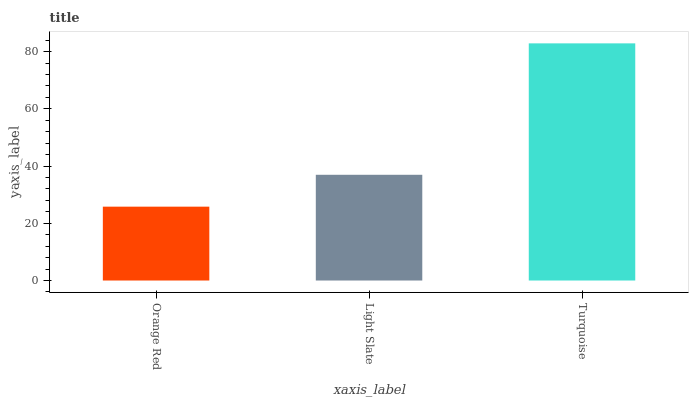Is Orange Red the minimum?
Answer yes or no. Yes. Is Turquoise the maximum?
Answer yes or no. Yes. Is Light Slate the minimum?
Answer yes or no. No. Is Light Slate the maximum?
Answer yes or no. No. Is Light Slate greater than Orange Red?
Answer yes or no. Yes. Is Orange Red less than Light Slate?
Answer yes or no. Yes. Is Orange Red greater than Light Slate?
Answer yes or no. No. Is Light Slate less than Orange Red?
Answer yes or no. No. Is Light Slate the high median?
Answer yes or no. Yes. Is Light Slate the low median?
Answer yes or no. Yes. Is Turquoise the high median?
Answer yes or no. No. Is Turquoise the low median?
Answer yes or no. No. 